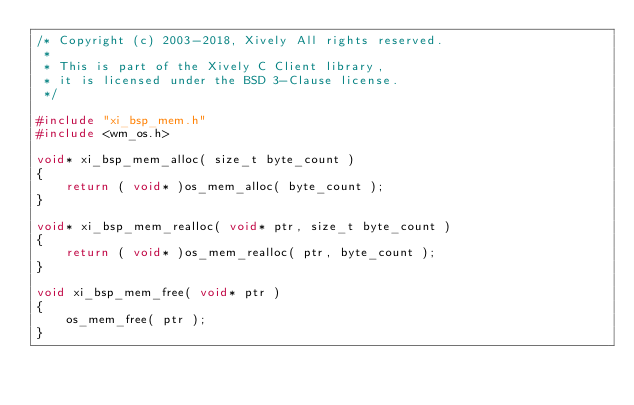<code> <loc_0><loc_0><loc_500><loc_500><_C_>/* Copyright (c) 2003-2018, Xively All rights reserved.
 *
 * This is part of the Xively C Client library,
 * it is licensed under the BSD 3-Clause license.
 */

#include "xi_bsp_mem.h"
#include <wm_os.h>

void* xi_bsp_mem_alloc( size_t byte_count )
{
    return ( void* )os_mem_alloc( byte_count );
}

void* xi_bsp_mem_realloc( void* ptr, size_t byte_count )
{
    return ( void* )os_mem_realloc( ptr, byte_count );
}

void xi_bsp_mem_free( void* ptr )
{
    os_mem_free( ptr );
}
</code> 